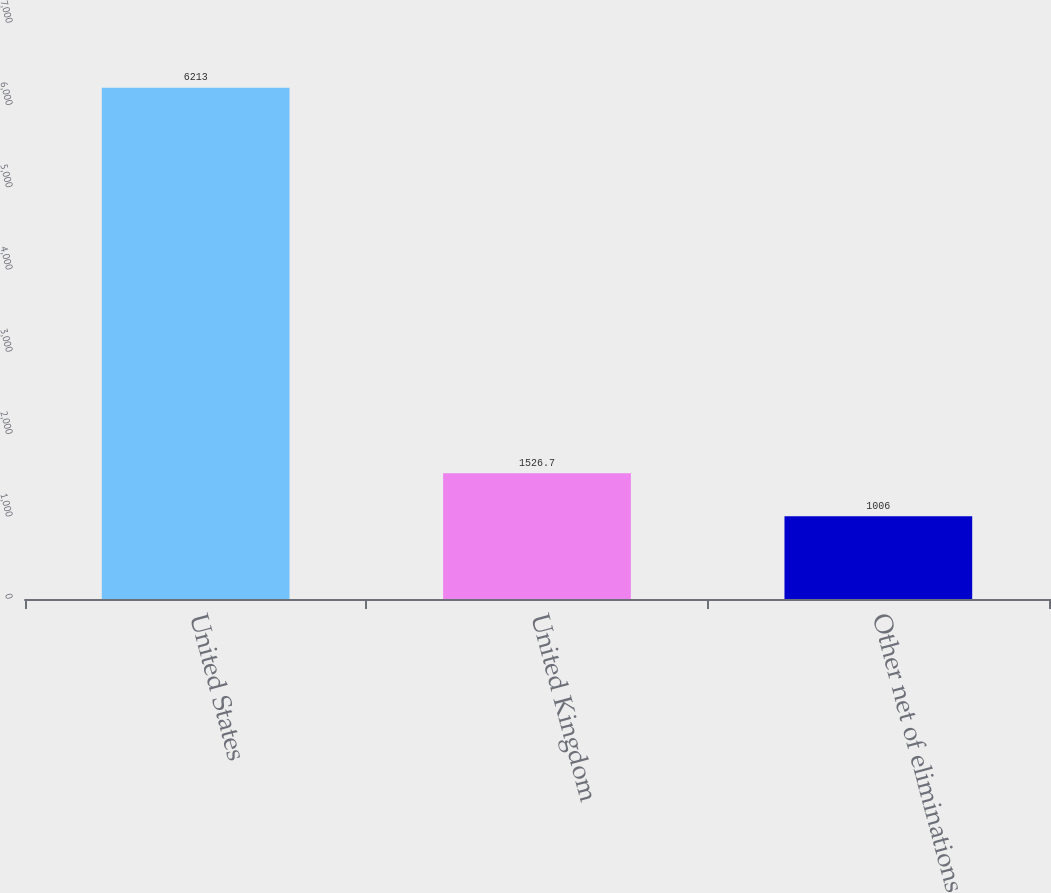<chart> <loc_0><loc_0><loc_500><loc_500><bar_chart><fcel>United States<fcel>United Kingdom<fcel>Other net of eliminations<nl><fcel>6213<fcel>1526.7<fcel>1006<nl></chart> 